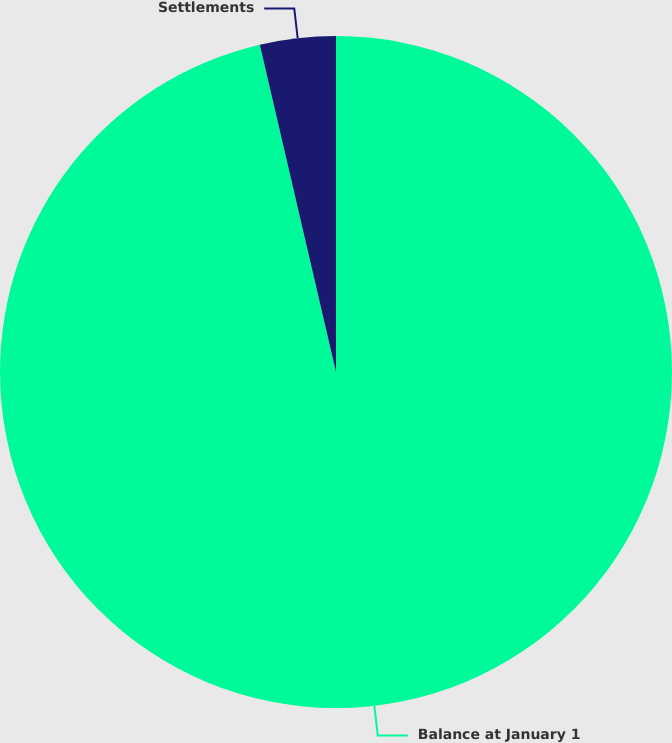<chart> <loc_0><loc_0><loc_500><loc_500><pie_chart><fcel>Balance at January 1<fcel>Settlements<nl><fcel>96.36%<fcel>3.64%<nl></chart> 